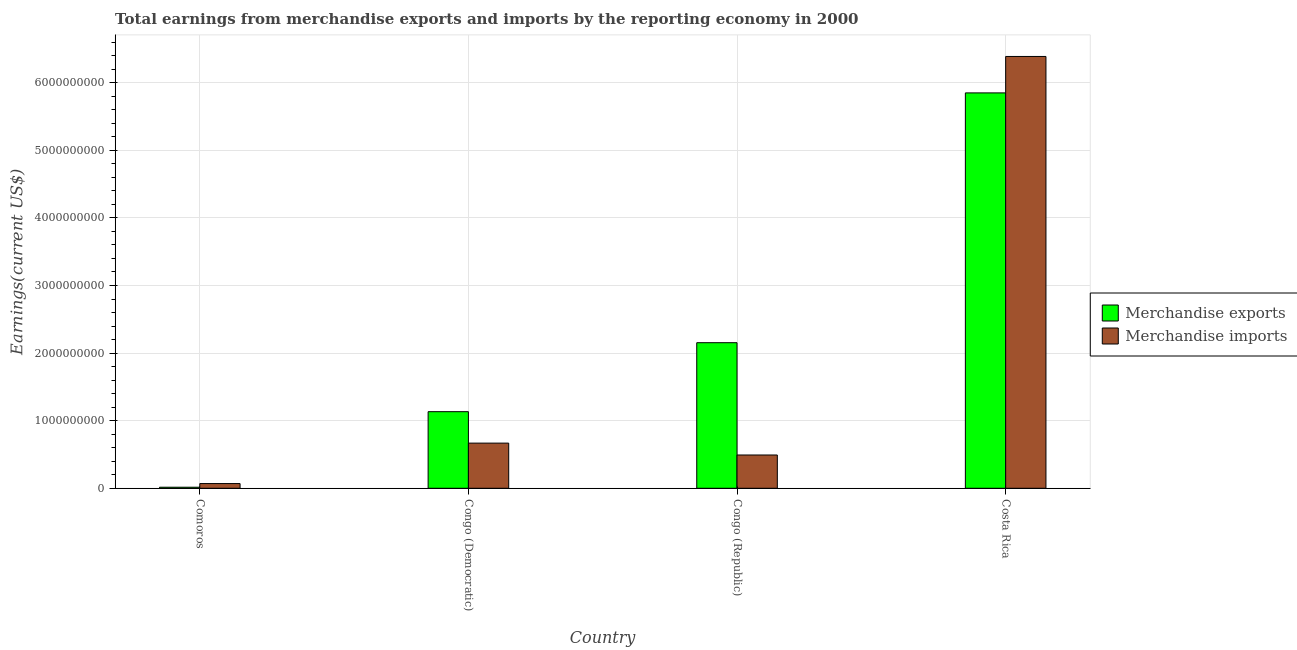Are the number of bars per tick equal to the number of legend labels?
Keep it short and to the point. Yes. Are the number of bars on each tick of the X-axis equal?
Offer a terse response. Yes. How many bars are there on the 1st tick from the left?
Your answer should be very brief. 2. How many bars are there on the 2nd tick from the right?
Offer a very short reply. 2. What is the label of the 4th group of bars from the left?
Make the answer very short. Costa Rica. In how many cases, is the number of bars for a given country not equal to the number of legend labels?
Keep it short and to the point. 0. What is the earnings from merchandise exports in Comoros?
Make the answer very short. 1.56e+07. Across all countries, what is the maximum earnings from merchandise exports?
Your answer should be very brief. 5.85e+09. Across all countries, what is the minimum earnings from merchandise exports?
Provide a succinct answer. 1.56e+07. In which country was the earnings from merchandise exports minimum?
Give a very brief answer. Comoros. What is the total earnings from merchandise exports in the graph?
Your response must be concise. 9.15e+09. What is the difference between the earnings from merchandise imports in Congo (Republic) and that in Costa Rica?
Your answer should be compact. -5.90e+09. What is the difference between the earnings from merchandise imports in Congo (Republic) and the earnings from merchandise exports in Congo (Democratic)?
Ensure brevity in your answer.  -6.41e+08. What is the average earnings from merchandise exports per country?
Ensure brevity in your answer.  2.29e+09. What is the difference between the earnings from merchandise exports and earnings from merchandise imports in Congo (Republic)?
Provide a short and direct response. 1.66e+09. In how many countries, is the earnings from merchandise exports greater than 4400000000 US$?
Your answer should be very brief. 1. What is the ratio of the earnings from merchandise imports in Comoros to that in Congo (Democratic)?
Offer a very short reply. 0.1. What is the difference between the highest and the second highest earnings from merchandise imports?
Your answer should be compact. 5.72e+09. What is the difference between the highest and the lowest earnings from merchandise imports?
Provide a short and direct response. 6.32e+09. Is the sum of the earnings from merchandise exports in Congo (Republic) and Costa Rica greater than the maximum earnings from merchandise imports across all countries?
Offer a terse response. Yes. Are all the bars in the graph horizontal?
Your answer should be very brief. No. How many countries are there in the graph?
Your answer should be compact. 4. What is the difference between two consecutive major ticks on the Y-axis?
Your response must be concise. 1.00e+09. Are the values on the major ticks of Y-axis written in scientific E-notation?
Provide a succinct answer. No. Does the graph contain any zero values?
Offer a very short reply. No. Does the graph contain grids?
Your answer should be compact. Yes. How many legend labels are there?
Your answer should be compact. 2. What is the title of the graph?
Provide a short and direct response. Total earnings from merchandise exports and imports by the reporting economy in 2000. What is the label or title of the Y-axis?
Your answer should be compact. Earnings(current US$). What is the Earnings(current US$) in Merchandise exports in Comoros?
Give a very brief answer. 1.56e+07. What is the Earnings(current US$) in Merchandise imports in Comoros?
Your response must be concise. 6.97e+07. What is the Earnings(current US$) in Merchandise exports in Congo (Democratic)?
Your answer should be compact. 1.13e+09. What is the Earnings(current US$) of Merchandise imports in Congo (Democratic)?
Make the answer very short. 6.68e+08. What is the Earnings(current US$) of Merchandise exports in Congo (Republic)?
Make the answer very short. 2.15e+09. What is the Earnings(current US$) in Merchandise imports in Congo (Republic)?
Keep it short and to the point. 4.92e+08. What is the Earnings(current US$) of Merchandise exports in Costa Rica?
Offer a terse response. 5.85e+09. What is the Earnings(current US$) of Merchandise imports in Costa Rica?
Your answer should be very brief. 6.39e+09. Across all countries, what is the maximum Earnings(current US$) of Merchandise exports?
Offer a very short reply. 5.85e+09. Across all countries, what is the maximum Earnings(current US$) in Merchandise imports?
Provide a short and direct response. 6.39e+09. Across all countries, what is the minimum Earnings(current US$) of Merchandise exports?
Offer a very short reply. 1.56e+07. Across all countries, what is the minimum Earnings(current US$) in Merchandise imports?
Your response must be concise. 6.97e+07. What is the total Earnings(current US$) in Merchandise exports in the graph?
Ensure brevity in your answer.  9.15e+09. What is the total Earnings(current US$) in Merchandise imports in the graph?
Your answer should be compact. 7.62e+09. What is the difference between the Earnings(current US$) in Merchandise exports in Comoros and that in Congo (Democratic)?
Your response must be concise. -1.12e+09. What is the difference between the Earnings(current US$) of Merchandise imports in Comoros and that in Congo (Democratic)?
Your answer should be very brief. -5.98e+08. What is the difference between the Earnings(current US$) in Merchandise exports in Comoros and that in Congo (Republic)?
Provide a succinct answer. -2.14e+09. What is the difference between the Earnings(current US$) of Merchandise imports in Comoros and that in Congo (Republic)?
Give a very brief answer. -4.23e+08. What is the difference between the Earnings(current US$) of Merchandise exports in Comoros and that in Costa Rica?
Make the answer very short. -5.83e+09. What is the difference between the Earnings(current US$) in Merchandise imports in Comoros and that in Costa Rica?
Make the answer very short. -6.32e+09. What is the difference between the Earnings(current US$) in Merchandise exports in Congo (Democratic) and that in Congo (Republic)?
Your response must be concise. -1.02e+09. What is the difference between the Earnings(current US$) in Merchandise imports in Congo (Democratic) and that in Congo (Republic)?
Your answer should be very brief. 1.76e+08. What is the difference between the Earnings(current US$) in Merchandise exports in Congo (Democratic) and that in Costa Rica?
Your answer should be very brief. -4.72e+09. What is the difference between the Earnings(current US$) of Merchandise imports in Congo (Democratic) and that in Costa Rica?
Keep it short and to the point. -5.72e+09. What is the difference between the Earnings(current US$) in Merchandise exports in Congo (Republic) and that in Costa Rica?
Provide a short and direct response. -3.70e+09. What is the difference between the Earnings(current US$) of Merchandise imports in Congo (Republic) and that in Costa Rica?
Provide a short and direct response. -5.90e+09. What is the difference between the Earnings(current US$) in Merchandise exports in Comoros and the Earnings(current US$) in Merchandise imports in Congo (Democratic)?
Ensure brevity in your answer.  -6.53e+08. What is the difference between the Earnings(current US$) of Merchandise exports in Comoros and the Earnings(current US$) of Merchandise imports in Congo (Republic)?
Keep it short and to the point. -4.77e+08. What is the difference between the Earnings(current US$) of Merchandise exports in Comoros and the Earnings(current US$) of Merchandise imports in Costa Rica?
Keep it short and to the point. -6.37e+09. What is the difference between the Earnings(current US$) in Merchandise exports in Congo (Democratic) and the Earnings(current US$) in Merchandise imports in Congo (Republic)?
Offer a terse response. 6.41e+08. What is the difference between the Earnings(current US$) of Merchandise exports in Congo (Democratic) and the Earnings(current US$) of Merchandise imports in Costa Rica?
Give a very brief answer. -5.26e+09. What is the difference between the Earnings(current US$) of Merchandise exports in Congo (Republic) and the Earnings(current US$) of Merchandise imports in Costa Rica?
Offer a terse response. -4.23e+09. What is the average Earnings(current US$) of Merchandise exports per country?
Give a very brief answer. 2.29e+09. What is the average Earnings(current US$) of Merchandise imports per country?
Provide a succinct answer. 1.90e+09. What is the difference between the Earnings(current US$) in Merchandise exports and Earnings(current US$) in Merchandise imports in Comoros?
Ensure brevity in your answer.  -5.42e+07. What is the difference between the Earnings(current US$) in Merchandise exports and Earnings(current US$) in Merchandise imports in Congo (Democratic)?
Your answer should be compact. 4.65e+08. What is the difference between the Earnings(current US$) in Merchandise exports and Earnings(current US$) in Merchandise imports in Congo (Republic)?
Your answer should be very brief. 1.66e+09. What is the difference between the Earnings(current US$) in Merchandise exports and Earnings(current US$) in Merchandise imports in Costa Rica?
Provide a succinct answer. -5.39e+08. What is the ratio of the Earnings(current US$) of Merchandise exports in Comoros to that in Congo (Democratic)?
Your answer should be compact. 0.01. What is the ratio of the Earnings(current US$) in Merchandise imports in Comoros to that in Congo (Democratic)?
Offer a terse response. 0.1. What is the ratio of the Earnings(current US$) in Merchandise exports in Comoros to that in Congo (Republic)?
Your answer should be compact. 0.01. What is the ratio of the Earnings(current US$) in Merchandise imports in Comoros to that in Congo (Republic)?
Provide a succinct answer. 0.14. What is the ratio of the Earnings(current US$) in Merchandise exports in Comoros to that in Costa Rica?
Give a very brief answer. 0. What is the ratio of the Earnings(current US$) in Merchandise imports in Comoros to that in Costa Rica?
Offer a terse response. 0.01. What is the ratio of the Earnings(current US$) in Merchandise exports in Congo (Democratic) to that in Congo (Republic)?
Your answer should be very brief. 0.53. What is the ratio of the Earnings(current US$) in Merchandise imports in Congo (Democratic) to that in Congo (Republic)?
Your response must be concise. 1.36. What is the ratio of the Earnings(current US$) of Merchandise exports in Congo (Democratic) to that in Costa Rica?
Offer a terse response. 0.19. What is the ratio of the Earnings(current US$) in Merchandise imports in Congo (Democratic) to that in Costa Rica?
Your answer should be compact. 0.1. What is the ratio of the Earnings(current US$) in Merchandise exports in Congo (Republic) to that in Costa Rica?
Make the answer very short. 0.37. What is the ratio of the Earnings(current US$) in Merchandise imports in Congo (Republic) to that in Costa Rica?
Keep it short and to the point. 0.08. What is the difference between the highest and the second highest Earnings(current US$) of Merchandise exports?
Make the answer very short. 3.70e+09. What is the difference between the highest and the second highest Earnings(current US$) in Merchandise imports?
Your answer should be very brief. 5.72e+09. What is the difference between the highest and the lowest Earnings(current US$) in Merchandise exports?
Provide a succinct answer. 5.83e+09. What is the difference between the highest and the lowest Earnings(current US$) of Merchandise imports?
Provide a succinct answer. 6.32e+09. 